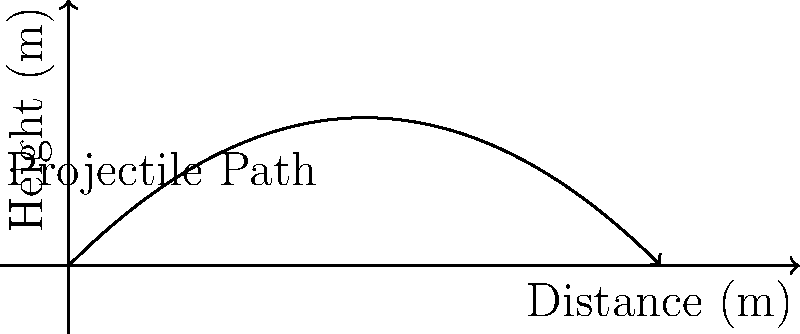In your historical drama set during a medieval siege, you want to accurately depict a catapult launching a projectile. The catapult launches a stone with an initial velocity of 50 m/s at an angle of 45° to the horizontal. Assuming negligible air resistance, what is the maximum height reached by the projectile? (Use $g = 9.8\, \text{m/s}^2$) To find the maximum height of the projectile, we can follow these steps:

1) The vertical component of the initial velocity is:
   $v_{0y} = v_0 \sin \theta = 50 \cdot \sin 45° = 50 \cdot \frac{\sqrt{2}}{2} \approx 35.36\, \text{m/s}$

2) The time to reach the maximum height is when the vertical velocity becomes zero:
   $v_y = v_{0y} - gt = 0$
   $t = \frac{v_{0y}}{g} = \frac{35.36}{9.8} \approx 3.61\, \text{s}$

3) The maximum height can be calculated using the equation:
   $h = v_{0y}t - \frac{1}{2}gt^2$

4) Substituting the values:
   $h = 35.36 \cdot 3.61 - \frac{1}{2} \cdot 9.8 \cdot 3.61^2$
   $h = 127.65 - 63.82 = 63.83\, \text{m}$

Therefore, the maximum height reached by the projectile is approximately 63.83 meters.
Answer: 63.83 m 